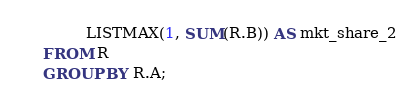Convert code to text. <code><loc_0><loc_0><loc_500><loc_500><_SQL_>         LISTMAX(1, SUM(R.B)) AS mkt_share_2
FROM R
GROUP BY R.A;
</code> 